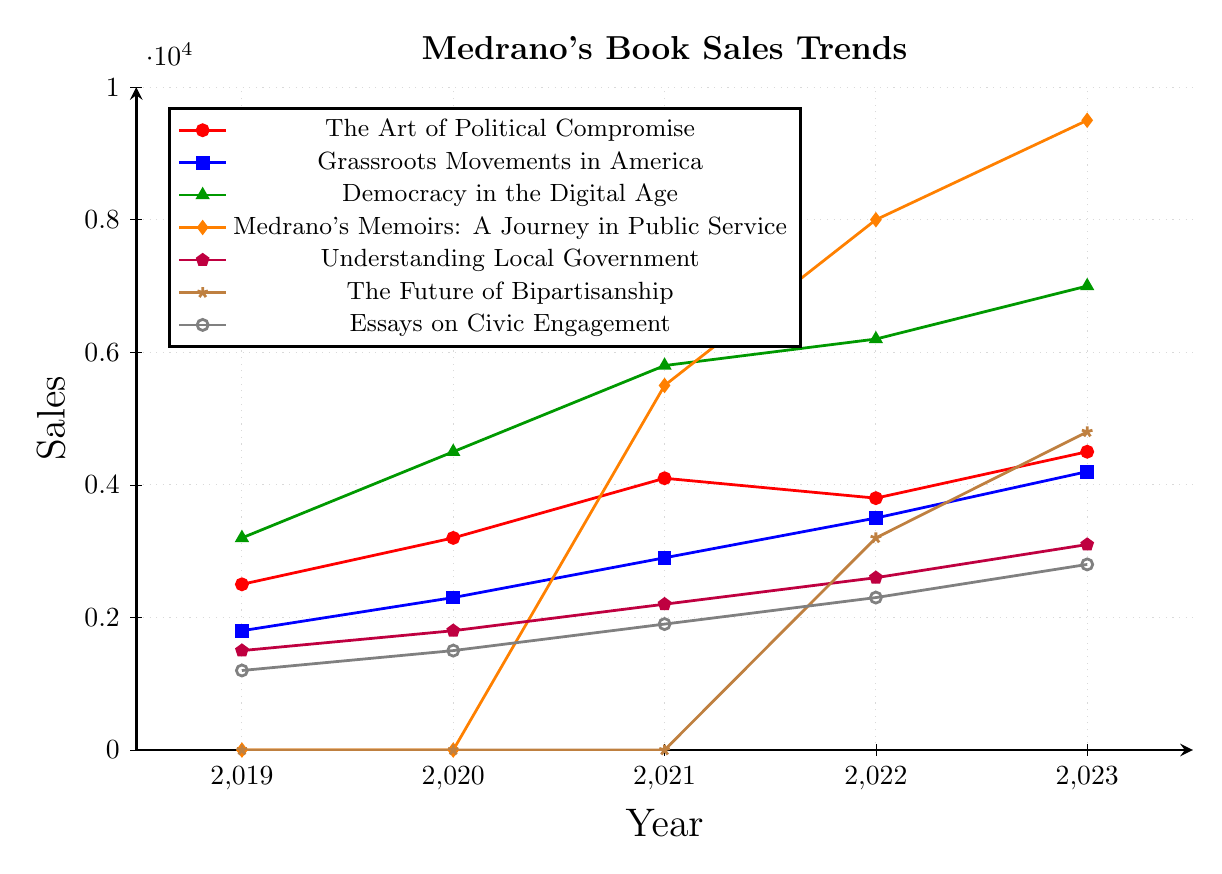Which book had the highest sales in 2023? Observing the chart, "Medrano's Memoirs: A Journey in Public Service" shows the highest point in 2023 with sales reaching 9500.
Answer: Medrano's Memoirs: A Journey in Public Service Which book had zero sales in 2019 and 2020 but showed sales increases starting in 2021? By looking at the lines in 2019 and 2020, "Medrano's Memoirs: A Journey in Public Service" and "The Future of Bipartisanship" both show zero sales but start increasing sales from 2021 and 2022 respectively. Only "Medrano's Memoirs: A Journey in Public Service" starts from 2021.
Answer: Medrano's Memoirs: A Journey in Public Service Which book had a steady increase in sales every year from 2019 to 2023? Observing the lines, "Grassroots Movements in America" shows a continuous increase in sales every year from 1800 in 2019 to 4200 in 2023.
Answer: Grassroots Movements in America What is the combined sales of "The Art of Political Compromise" and "Democracy in the Digital Age" in 2022? Summing the sales of both books in 2022: "The Art of Political Compromise" (3800) + "Democracy in the Digital Age" (6200).
Answer: 10000 Which book had the greatest increase in sales between 2021 and 2022? Looking at the differences, "Medrano's Memoirs: A Journey in Public Service" increased from 5500 to 8000, a difference of 2500. Other books had smaller increases.
Answer: Medrano's Memoirs: A Journey in Public Service Between "Understanding Local Government" and "Essays on Civic Engagement," which had higher sales in 2020? Checking the chart, "Understanding Local Government" had sales of 1800 in 2020, while "Essays on Civic Engagement" had sales of 1500.
Answer: Understanding Local Government How many books had sales below 3000 in 2023? There are two books with sales below 3000 in 2023: "Understanding Local Government" (3100), and "Essays on Civic Engagement" (2800). Corrected sales below 3000. "Essays on Civic Engagement" with sales of 2800 falls in this range.
Answer: 1 What was the total sales for "The Future of Bipartisanship" over the years it had sales? Summing the sales: 3200 (2022) + 4800 (2023).
Answer: 8000 